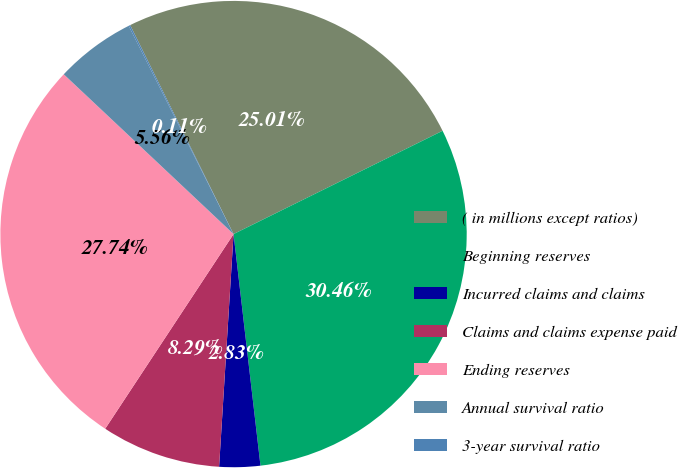<chart> <loc_0><loc_0><loc_500><loc_500><pie_chart><fcel>( in millions except ratios)<fcel>Beginning reserves<fcel>Incurred claims and claims<fcel>Claims and claims expense paid<fcel>Ending reserves<fcel>Annual survival ratio<fcel>3-year survival ratio<nl><fcel>25.01%<fcel>30.46%<fcel>2.83%<fcel>8.29%<fcel>27.74%<fcel>5.56%<fcel>0.11%<nl></chart> 